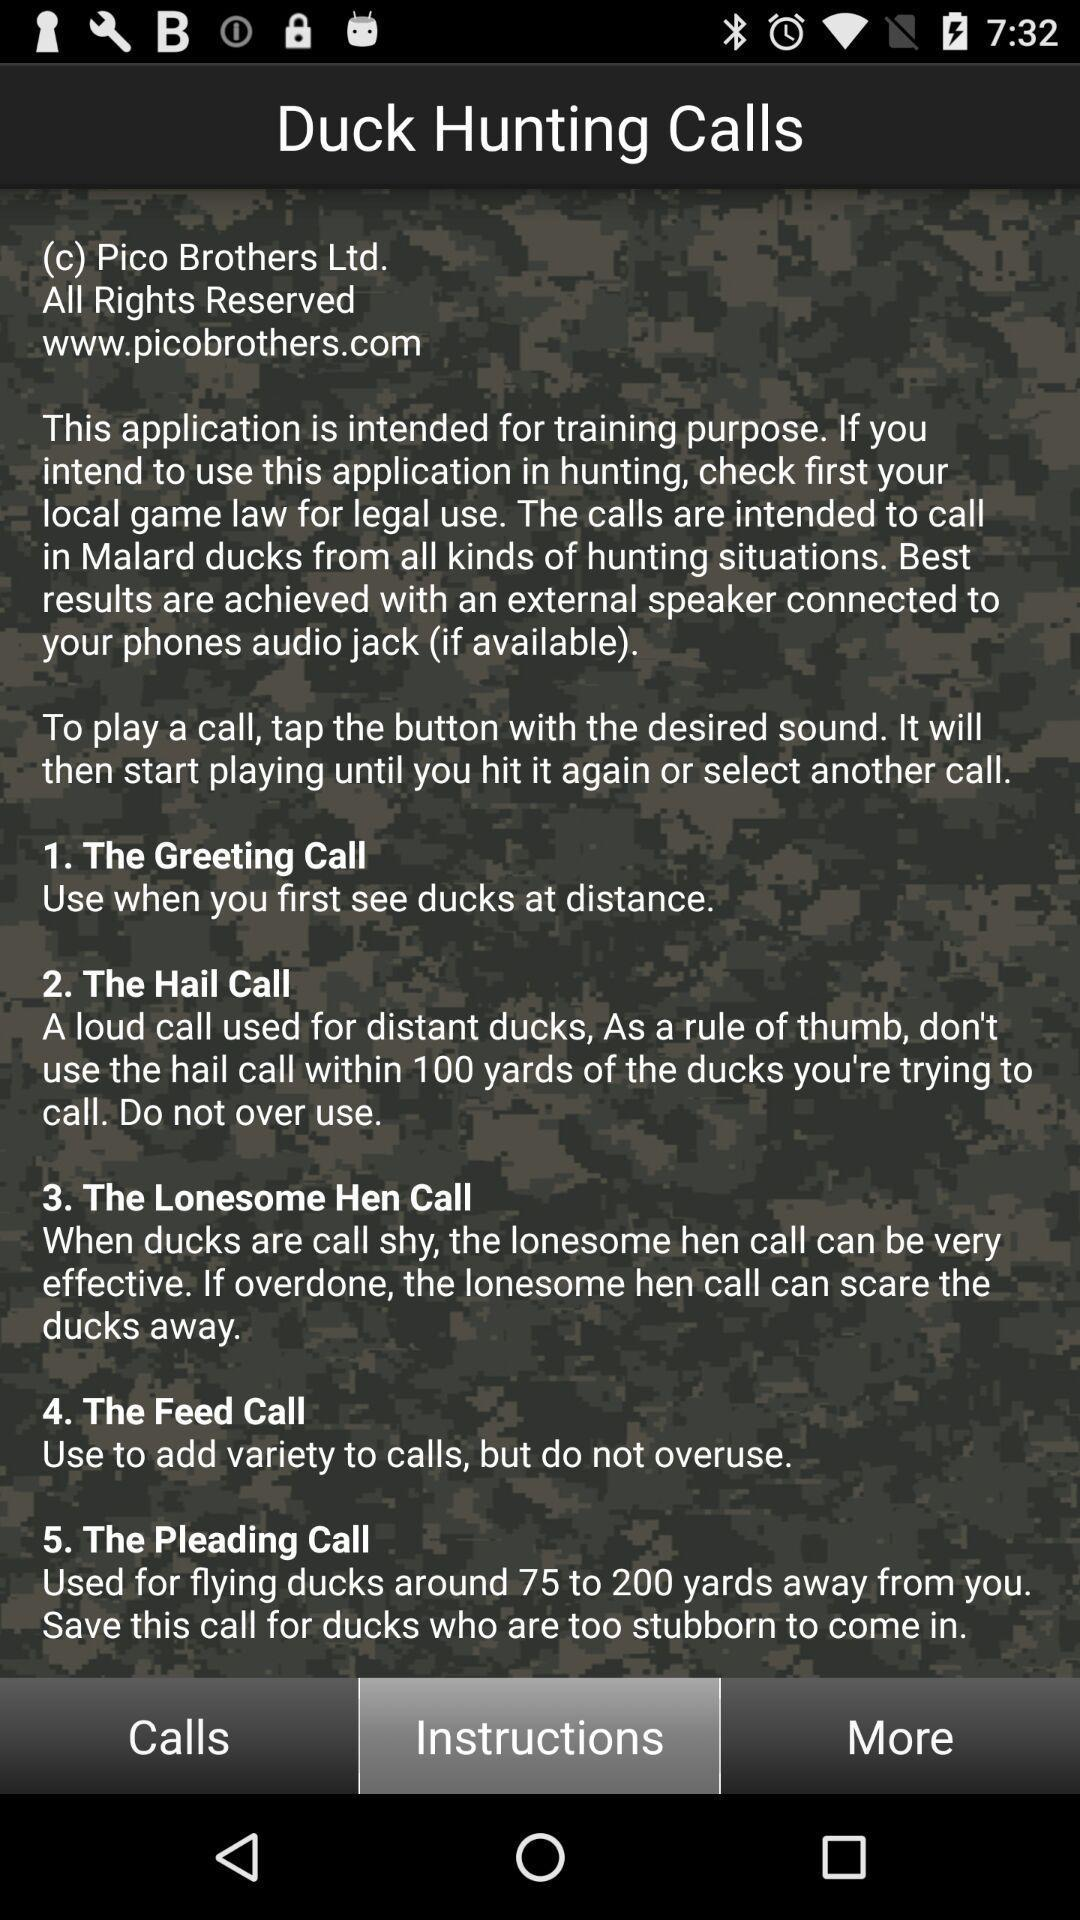How many calls are there in total?
Answer the question using a single word or phrase. 5 